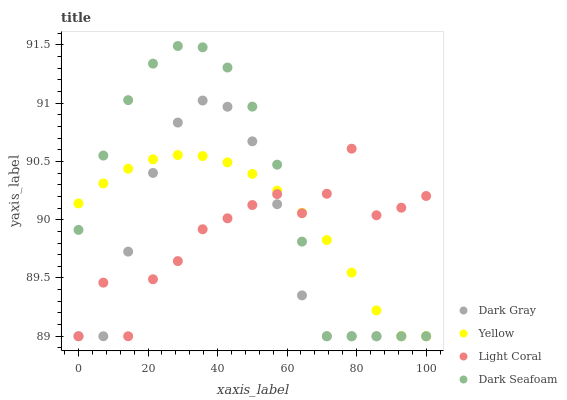Does Dark Gray have the minimum area under the curve?
Answer yes or no. Yes. Does Dark Seafoam have the maximum area under the curve?
Answer yes or no. Yes. Does Light Coral have the minimum area under the curve?
Answer yes or no. No. Does Light Coral have the maximum area under the curve?
Answer yes or no. No. Is Yellow the smoothest?
Answer yes or no. Yes. Is Light Coral the roughest?
Answer yes or no. Yes. Is Dark Seafoam the smoothest?
Answer yes or no. No. Is Dark Seafoam the roughest?
Answer yes or no. No. Does Dark Gray have the lowest value?
Answer yes or no. Yes. Does Dark Seafoam have the highest value?
Answer yes or no. Yes. Does Light Coral have the highest value?
Answer yes or no. No. Does Yellow intersect Dark Seafoam?
Answer yes or no. Yes. Is Yellow less than Dark Seafoam?
Answer yes or no. No. Is Yellow greater than Dark Seafoam?
Answer yes or no. No. 